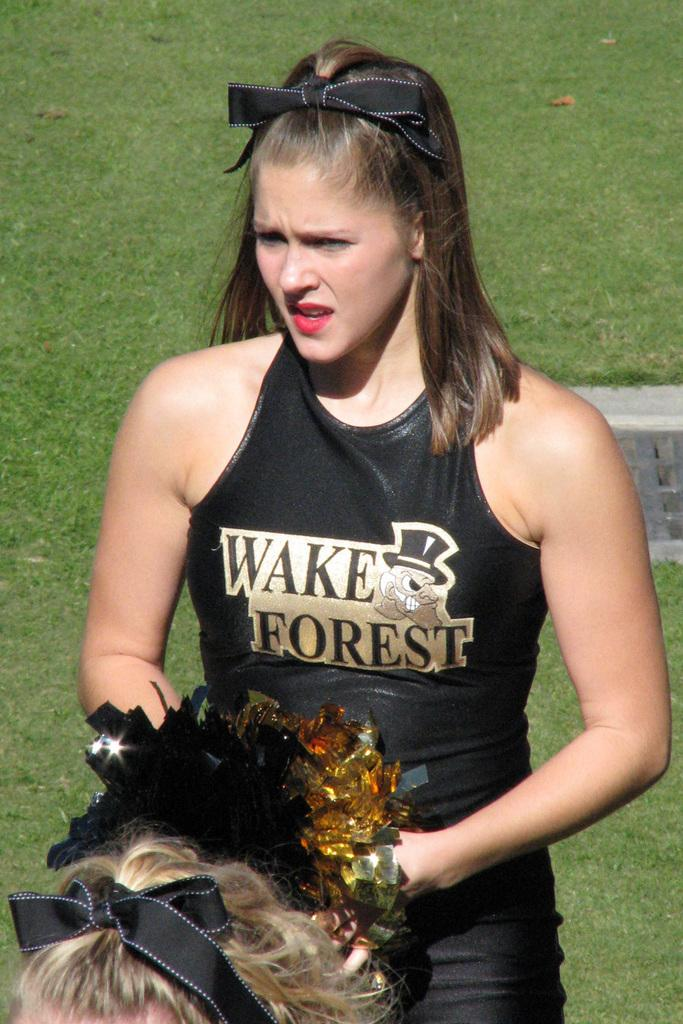<image>
Present a compact description of the photo's key features. A cheerleader for Wake forest hold a pair of black and gold pom poms. 